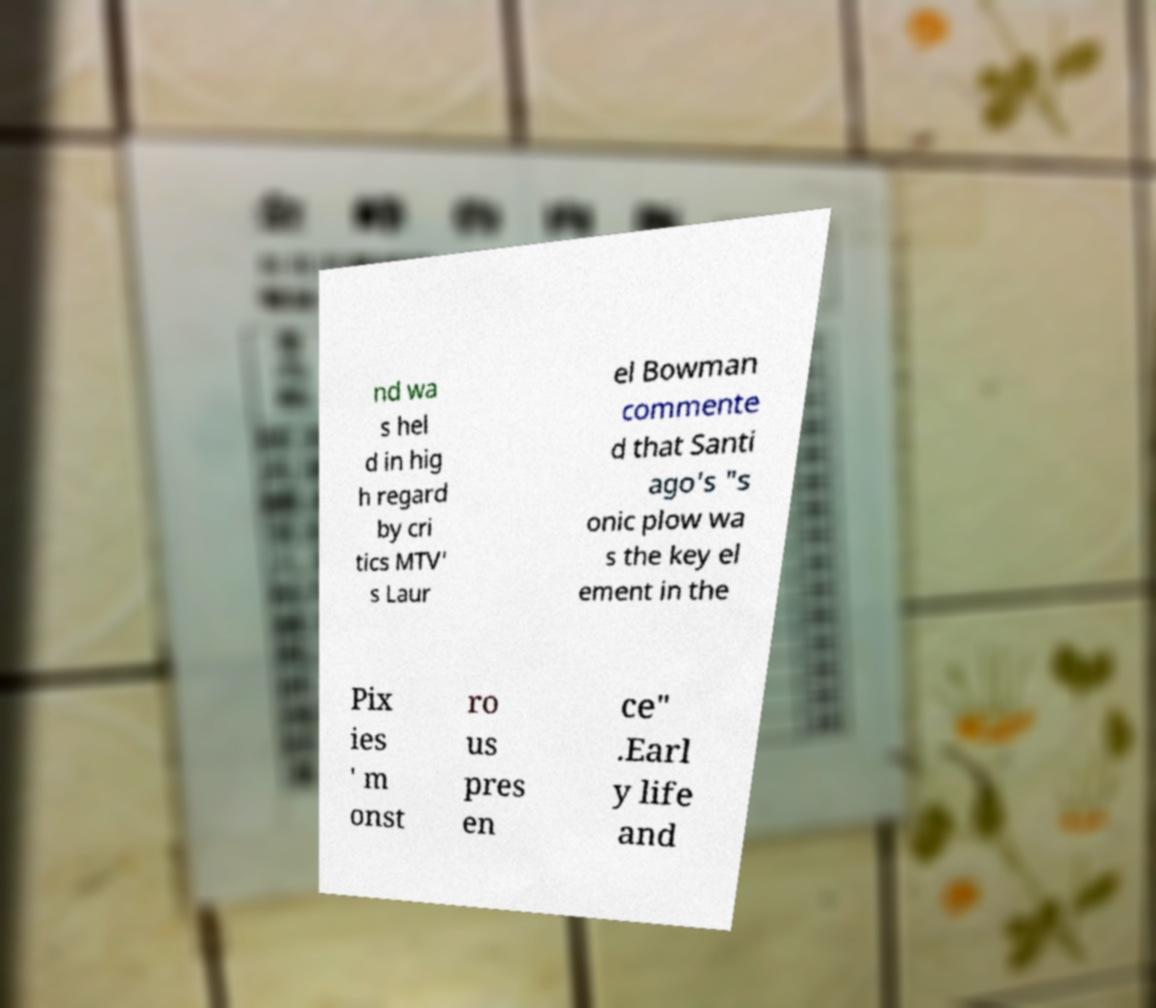Can you read and provide the text displayed in the image?This photo seems to have some interesting text. Can you extract and type it out for me? nd wa s hel d in hig h regard by cri tics MTV' s Laur el Bowman commente d that Santi ago's "s onic plow wa s the key el ement in the Pix ies ' m onst ro us pres en ce" .Earl y life and 